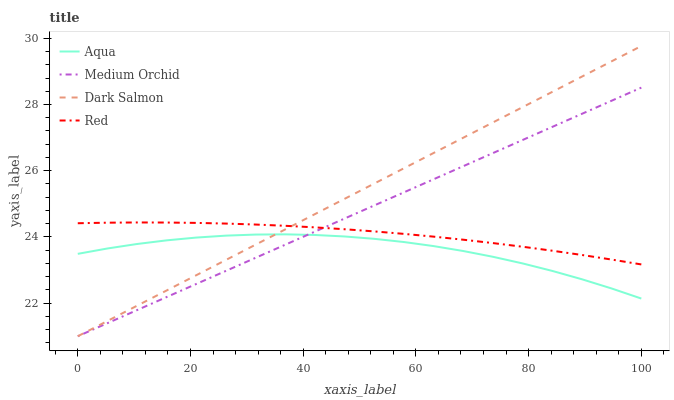Does Aqua have the minimum area under the curve?
Answer yes or no. Yes. Does Dark Salmon have the maximum area under the curve?
Answer yes or no. Yes. Does Dark Salmon have the minimum area under the curve?
Answer yes or no. No. Does Aqua have the maximum area under the curve?
Answer yes or no. No. Is Dark Salmon the smoothest?
Answer yes or no. Yes. Is Aqua the roughest?
Answer yes or no. Yes. Is Aqua the smoothest?
Answer yes or no. No. Is Dark Salmon the roughest?
Answer yes or no. No. Does Aqua have the lowest value?
Answer yes or no. No. Does Aqua have the highest value?
Answer yes or no. No. Is Aqua less than Red?
Answer yes or no. Yes. Is Red greater than Aqua?
Answer yes or no. Yes. Does Aqua intersect Red?
Answer yes or no. No. 